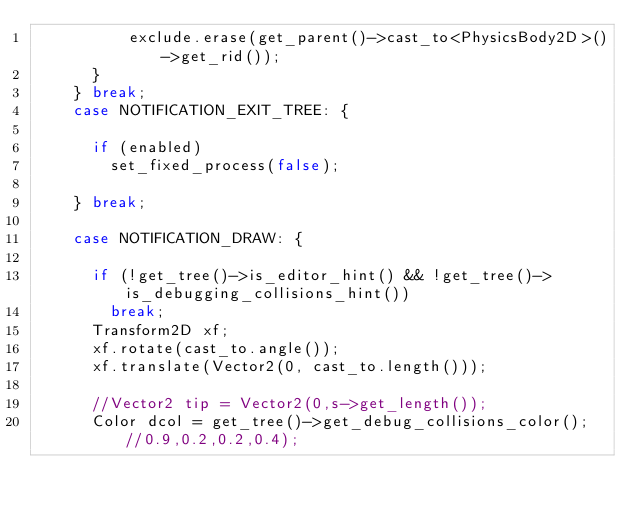Convert code to text. <code><loc_0><loc_0><loc_500><loc_500><_C++_>					exclude.erase(get_parent()->cast_to<PhysicsBody2D>()->get_rid());
			}
		} break;
		case NOTIFICATION_EXIT_TREE: {

			if (enabled)
				set_fixed_process(false);

		} break;

		case NOTIFICATION_DRAW: {

			if (!get_tree()->is_editor_hint() && !get_tree()->is_debugging_collisions_hint())
				break;
			Transform2D xf;
			xf.rotate(cast_to.angle());
			xf.translate(Vector2(0, cast_to.length()));

			//Vector2 tip = Vector2(0,s->get_length());
			Color dcol = get_tree()->get_debug_collisions_color(); //0.9,0.2,0.2,0.4);</code> 